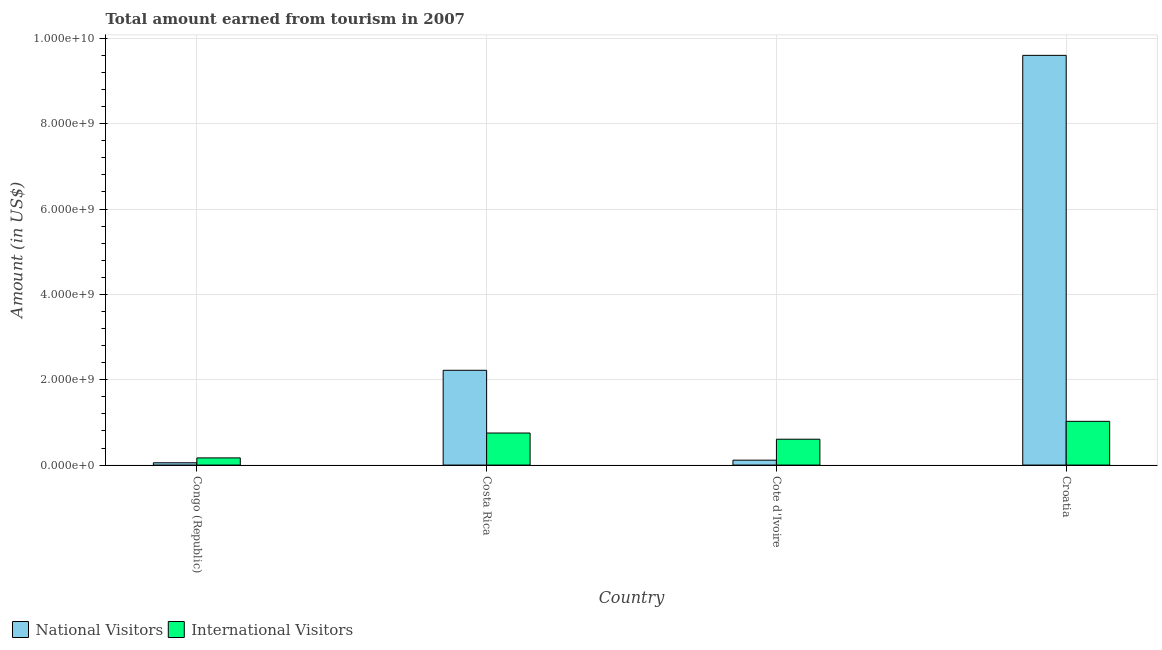How many different coloured bars are there?
Offer a very short reply. 2. Are the number of bars per tick equal to the number of legend labels?
Your response must be concise. Yes. How many bars are there on the 1st tick from the left?
Your response must be concise. 2. How many bars are there on the 1st tick from the right?
Your answer should be compact. 2. What is the label of the 3rd group of bars from the left?
Your answer should be compact. Cote d'Ivoire. In how many cases, is the number of bars for a given country not equal to the number of legend labels?
Offer a very short reply. 0. What is the amount earned from national visitors in Croatia?
Your response must be concise. 9.60e+09. Across all countries, what is the maximum amount earned from national visitors?
Your answer should be compact. 9.60e+09. Across all countries, what is the minimum amount earned from national visitors?
Make the answer very short. 5.40e+07. In which country was the amount earned from national visitors maximum?
Keep it short and to the point. Croatia. In which country was the amount earned from international visitors minimum?
Keep it short and to the point. Congo (Republic). What is the total amount earned from national visitors in the graph?
Offer a terse response. 1.20e+1. What is the difference between the amount earned from international visitors in Congo (Republic) and that in Croatia?
Offer a very short reply. -8.57e+08. What is the difference between the amount earned from international visitors in Congo (Republic) and the amount earned from national visitors in Costa Rica?
Your response must be concise. -2.05e+09. What is the average amount earned from international visitors per country?
Provide a succinct answer. 6.38e+08. What is the difference between the amount earned from national visitors and amount earned from international visitors in Costa Rica?
Your answer should be compact. 1.47e+09. In how many countries, is the amount earned from national visitors greater than 4800000000 US$?
Make the answer very short. 1. What is the ratio of the amount earned from international visitors in Congo (Republic) to that in Cote d'Ivoire?
Your answer should be compact. 0.28. Is the amount earned from national visitors in Costa Rica less than that in Cote d'Ivoire?
Keep it short and to the point. No. Is the difference between the amount earned from national visitors in Congo (Republic) and Cote d'Ivoire greater than the difference between the amount earned from international visitors in Congo (Republic) and Cote d'Ivoire?
Make the answer very short. Yes. What is the difference between the highest and the second highest amount earned from national visitors?
Your answer should be compact. 7.38e+09. What is the difference between the highest and the lowest amount earned from national visitors?
Provide a succinct answer. 9.55e+09. In how many countries, is the amount earned from national visitors greater than the average amount earned from national visitors taken over all countries?
Your answer should be very brief. 1. Is the sum of the amount earned from international visitors in Costa Rica and Croatia greater than the maximum amount earned from national visitors across all countries?
Provide a short and direct response. No. What does the 2nd bar from the left in Congo (Republic) represents?
Offer a terse response. International Visitors. What does the 1st bar from the right in Congo (Republic) represents?
Make the answer very short. International Visitors. How many countries are there in the graph?
Ensure brevity in your answer.  4. Are the values on the major ticks of Y-axis written in scientific E-notation?
Offer a very short reply. Yes. How many legend labels are there?
Offer a terse response. 2. What is the title of the graph?
Your response must be concise. Total amount earned from tourism in 2007. Does "Malaria" appear as one of the legend labels in the graph?
Provide a succinct answer. No. What is the label or title of the Y-axis?
Your response must be concise. Amount (in US$). What is the Amount (in US$) of National Visitors in Congo (Republic)?
Give a very brief answer. 5.40e+07. What is the Amount (in US$) of International Visitors in Congo (Republic)?
Ensure brevity in your answer.  1.68e+08. What is the Amount (in US$) in National Visitors in Costa Rica?
Your answer should be compact. 2.22e+09. What is the Amount (in US$) of International Visitors in Costa Rica?
Make the answer very short. 7.51e+08. What is the Amount (in US$) of National Visitors in Cote d'Ivoire?
Your answer should be compact. 1.15e+08. What is the Amount (in US$) in International Visitors in Cote d'Ivoire?
Offer a very short reply. 6.06e+08. What is the Amount (in US$) of National Visitors in Croatia?
Ensure brevity in your answer.  9.60e+09. What is the Amount (in US$) of International Visitors in Croatia?
Ensure brevity in your answer.  1.02e+09. Across all countries, what is the maximum Amount (in US$) of National Visitors?
Keep it short and to the point. 9.60e+09. Across all countries, what is the maximum Amount (in US$) of International Visitors?
Provide a short and direct response. 1.02e+09. Across all countries, what is the minimum Amount (in US$) of National Visitors?
Keep it short and to the point. 5.40e+07. Across all countries, what is the minimum Amount (in US$) in International Visitors?
Your response must be concise. 1.68e+08. What is the total Amount (in US$) of National Visitors in the graph?
Provide a succinct answer. 1.20e+1. What is the total Amount (in US$) in International Visitors in the graph?
Provide a succinct answer. 2.55e+09. What is the difference between the Amount (in US$) in National Visitors in Congo (Republic) and that in Costa Rica?
Ensure brevity in your answer.  -2.17e+09. What is the difference between the Amount (in US$) of International Visitors in Congo (Republic) and that in Costa Rica?
Offer a terse response. -5.83e+08. What is the difference between the Amount (in US$) in National Visitors in Congo (Republic) and that in Cote d'Ivoire?
Your answer should be very brief. -6.10e+07. What is the difference between the Amount (in US$) in International Visitors in Congo (Republic) and that in Cote d'Ivoire?
Your answer should be compact. -4.38e+08. What is the difference between the Amount (in US$) in National Visitors in Congo (Republic) and that in Croatia?
Provide a short and direct response. -9.55e+09. What is the difference between the Amount (in US$) of International Visitors in Congo (Republic) and that in Croatia?
Offer a terse response. -8.57e+08. What is the difference between the Amount (in US$) in National Visitors in Costa Rica and that in Cote d'Ivoire?
Provide a short and direct response. 2.11e+09. What is the difference between the Amount (in US$) of International Visitors in Costa Rica and that in Cote d'Ivoire?
Ensure brevity in your answer.  1.45e+08. What is the difference between the Amount (in US$) of National Visitors in Costa Rica and that in Croatia?
Give a very brief answer. -7.38e+09. What is the difference between the Amount (in US$) of International Visitors in Costa Rica and that in Croatia?
Your answer should be very brief. -2.74e+08. What is the difference between the Amount (in US$) of National Visitors in Cote d'Ivoire and that in Croatia?
Keep it short and to the point. -9.49e+09. What is the difference between the Amount (in US$) in International Visitors in Cote d'Ivoire and that in Croatia?
Your answer should be very brief. -4.19e+08. What is the difference between the Amount (in US$) of National Visitors in Congo (Republic) and the Amount (in US$) of International Visitors in Costa Rica?
Your response must be concise. -6.97e+08. What is the difference between the Amount (in US$) of National Visitors in Congo (Republic) and the Amount (in US$) of International Visitors in Cote d'Ivoire?
Your response must be concise. -5.52e+08. What is the difference between the Amount (in US$) in National Visitors in Congo (Republic) and the Amount (in US$) in International Visitors in Croatia?
Give a very brief answer. -9.71e+08. What is the difference between the Amount (in US$) in National Visitors in Costa Rica and the Amount (in US$) in International Visitors in Cote d'Ivoire?
Your answer should be very brief. 1.62e+09. What is the difference between the Amount (in US$) of National Visitors in Costa Rica and the Amount (in US$) of International Visitors in Croatia?
Your answer should be compact. 1.20e+09. What is the difference between the Amount (in US$) of National Visitors in Cote d'Ivoire and the Amount (in US$) of International Visitors in Croatia?
Your response must be concise. -9.10e+08. What is the average Amount (in US$) of National Visitors per country?
Make the answer very short. 3.00e+09. What is the average Amount (in US$) of International Visitors per country?
Make the answer very short. 6.38e+08. What is the difference between the Amount (in US$) in National Visitors and Amount (in US$) in International Visitors in Congo (Republic)?
Make the answer very short. -1.14e+08. What is the difference between the Amount (in US$) of National Visitors and Amount (in US$) of International Visitors in Costa Rica?
Your answer should be compact. 1.47e+09. What is the difference between the Amount (in US$) of National Visitors and Amount (in US$) of International Visitors in Cote d'Ivoire?
Keep it short and to the point. -4.91e+08. What is the difference between the Amount (in US$) of National Visitors and Amount (in US$) of International Visitors in Croatia?
Provide a short and direct response. 8.58e+09. What is the ratio of the Amount (in US$) in National Visitors in Congo (Republic) to that in Costa Rica?
Your answer should be compact. 0.02. What is the ratio of the Amount (in US$) of International Visitors in Congo (Republic) to that in Costa Rica?
Your answer should be very brief. 0.22. What is the ratio of the Amount (in US$) of National Visitors in Congo (Republic) to that in Cote d'Ivoire?
Provide a succinct answer. 0.47. What is the ratio of the Amount (in US$) in International Visitors in Congo (Republic) to that in Cote d'Ivoire?
Your response must be concise. 0.28. What is the ratio of the Amount (in US$) in National Visitors in Congo (Republic) to that in Croatia?
Provide a short and direct response. 0.01. What is the ratio of the Amount (in US$) of International Visitors in Congo (Republic) to that in Croatia?
Offer a terse response. 0.16. What is the ratio of the Amount (in US$) in National Visitors in Costa Rica to that in Cote d'Ivoire?
Your answer should be compact. 19.31. What is the ratio of the Amount (in US$) of International Visitors in Costa Rica to that in Cote d'Ivoire?
Provide a succinct answer. 1.24. What is the ratio of the Amount (in US$) of National Visitors in Costa Rica to that in Croatia?
Offer a very short reply. 0.23. What is the ratio of the Amount (in US$) in International Visitors in Costa Rica to that in Croatia?
Offer a terse response. 0.73. What is the ratio of the Amount (in US$) of National Visitors in Cote d'Ivoire to that in Croatia?
Your response must be concise. 0.01. What is the ratio of the Amount (in US$) of International Visitors in Cote d'Ivoire to that in Croatia?
Provide a succinct answer. 0.59. What is the difference between the highest and the second highest Amount (in US$) of National Visitors?
Your answer should be compact. 7.38e+09. What is the difference between the highest and the second highest Amount (in US$) of International Visitors?
Make the answer very short. 2.74e+08. What is the difference between the highest and the lowest Amount (in US$) of National Visitors?
Your response must be concise. 9.55e+09. What is the difference between the highest and the lowest Amount (in US$) of International Visitors?
Provide a short and direct response. 8.57e+08. 